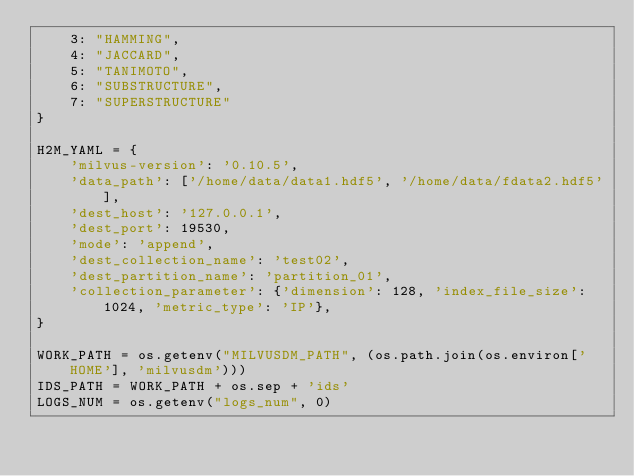<code> <loc_0><loc_0><loc_500><loc_500><_Python_>    3: "HAMMING",
    4: "JACCARD",
    5: "TANIMOTO",
    6: "SUBSTRUCTURE",
    7: "SUPERSTRUCTURE"
}

H2M_YAML = {
    'milvus-version': '0.10.5',
    'data_path': ['/home/data/data1.hdf5', '/home/data/fdata2.hdf5'],
    'dest_host': '127.0.0.1',
    'dest_port': 19530,
    'mode': 'append',
    'dest_collection_name': 'test02',
    'dest_partition_name': 'partition_01',
    'collection_parameter': {'dimension': 128, 'index_file_size': 1024, 'metric_type': 'IP'},
}

WORK_PATH = os.getenv("MILVUSDM_PATH", (os.path.join(os.environ['HOME'], 'milvusdm')))
IDS_PATH = WORK_PATH + os.sep + 'ids'
LOGS_NUM = os.getenv("logs_num", 0)
</code> 